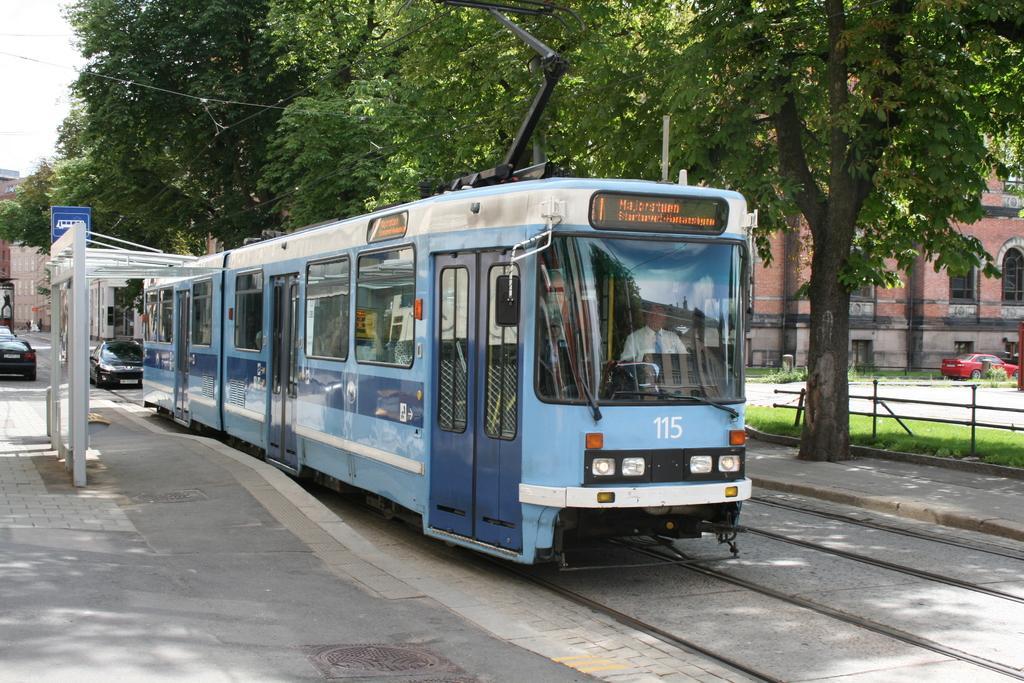Describe this image in one or two sentences. In this picture we can see white and blue color tram park on the tram stop. Beside we can see tram station. In the background we can see a black color car. On the right side we can see many trees and brown color building with arch windows. 